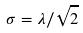<formula> <loc_0><loc_0><loc_500><loc_500>\sigma = \lambda / \sqrt { 2 }</formula> 